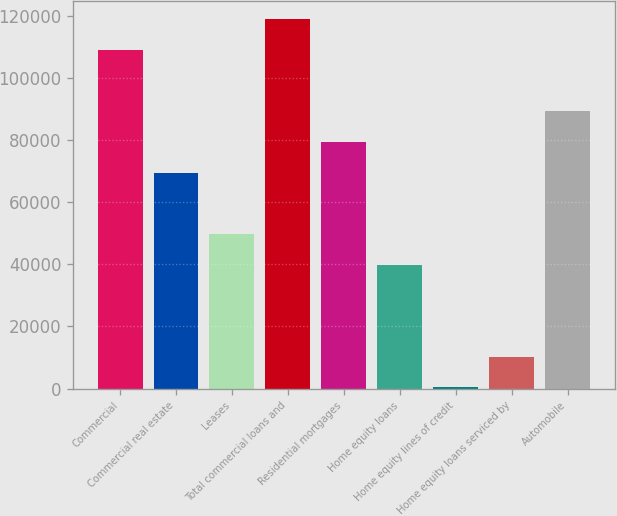Convert chart to OTSL. <chart><loc_0><loc_0><loc_500><loc_500><bar_chart><fcel>Commercial<fcel>Commercial real estate<fcel>Leases<fcel>Total commercial loans and<fcel>Residential mortgages<fcel>Home equity loans<fcel>Home equity lines of credit<fcel>Home equity loans serviced by<fcel>Automobile<nl><fcel>108907<fcel>69446.1<fcel>49715.5<fcel>118773<fcel>79311.4<fcel>39850.2<fcel>389<fcel>10254.3<fcel>89176.7<nl></chart> 